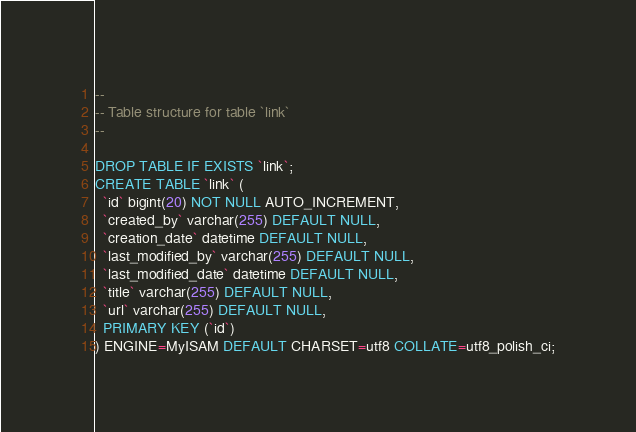<code> <loc_0><loc_0><loc_500><loc_500><_SQL_>
--
-- Table structure for table `link`
--

DROP TABLE IF EXISTS `link`;
CREATE TABLE `link` (
  `id` bigint(20) NOT NULL AUTO_INCREMENT,
  `created_by` varchar(255) DEFAULT NULL,
  `creation_date` datetime DEFAULT NULL,
  `last_modified_by` varchar(255) DEFAULT NULL,
  `last_modified_date` datetime DEFAULT NULL,
  `title` varchar(255) DEFAULT NULL,
  `url` varchar(255) DEFAULT NULL,
  PRIMARY KEY (`id`)
) ENGINE=MyISAM DEFAULT CHARSET=utf8 COLLATE=utf8_polish_ci;</code> 